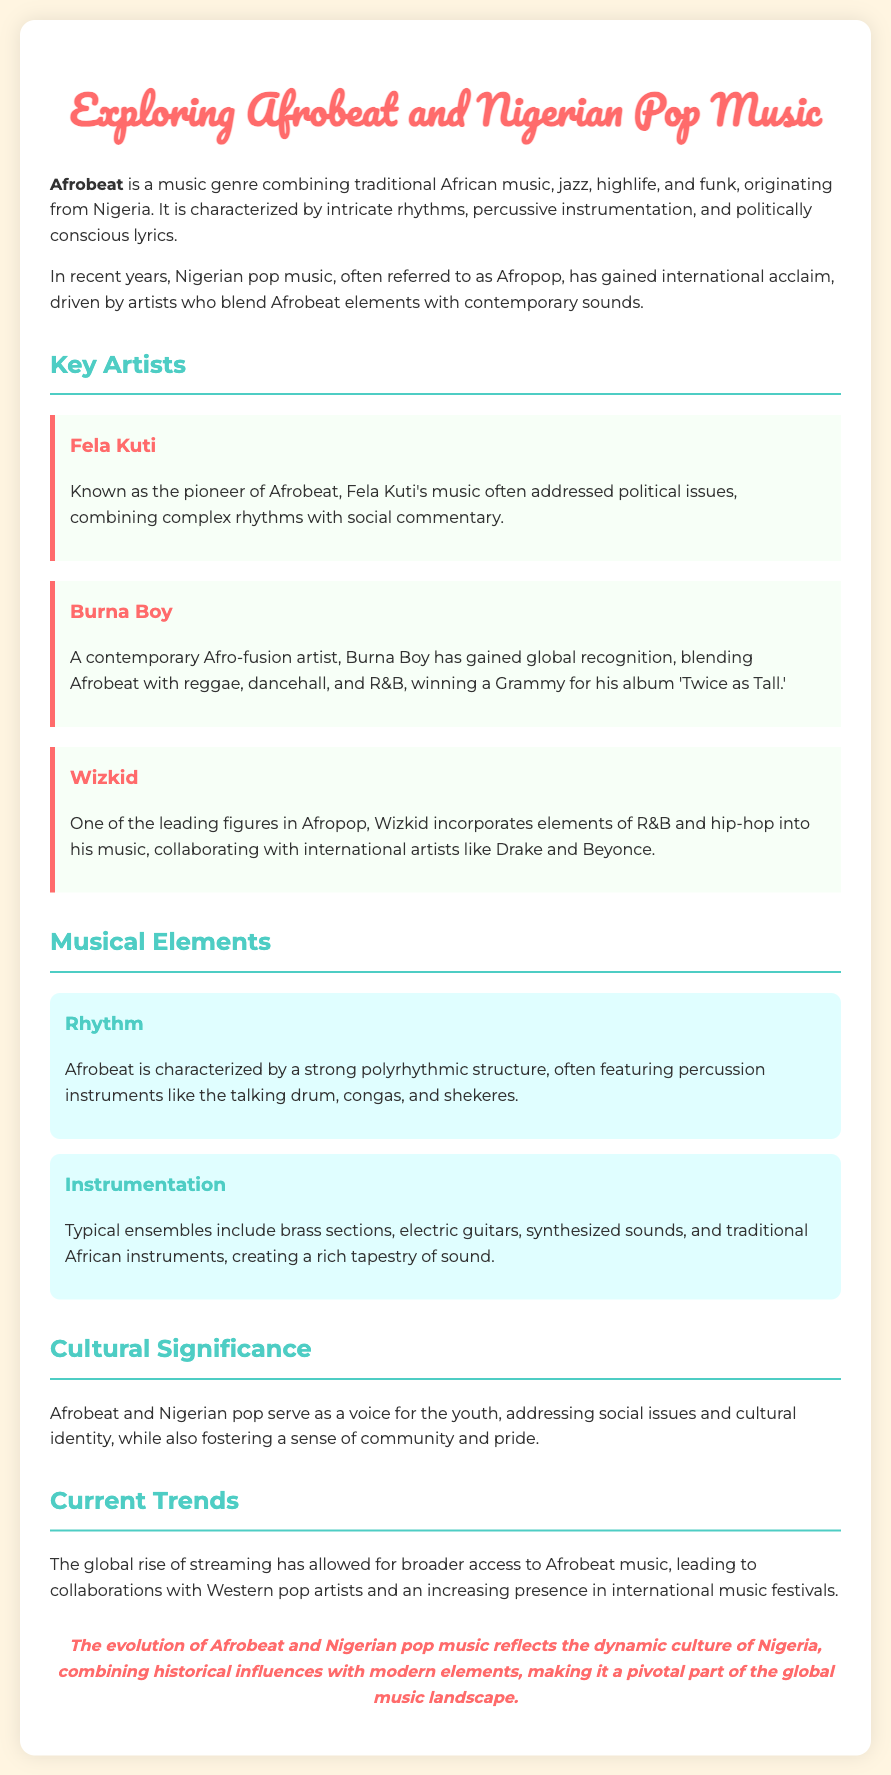What genre combines traditional African music, jazz, highlife, and funk? The document states that Afrobeat is a music genre that combines these elements.
Answer: Afrobeat Who is known as the pioneer of Afrobeat? The document mentions Fela Kuti as the pioneer of Afrobeat.
Answer: Fela Kuti Which artist won a Grammy for the album 'Twice as Tall'? The document specifies that Burna Boy won a Grammy for this album.
Answer: Burna Boy What is a characteristic feature of Afrobeat's rhythm? The document describes Afrobeat as having a strong polyrhythmic structure.
Answer: Polyrhythmic structure Which two genres does Wizkid incorporate into his music? The document indicates that Wizkid incorporates R&B and hip-hop.
Answer: R&B and hip-hop What type of cultural issues do Afrobeat and Nigerian pop music address? The document states that they serve as a voice for social issues and cultural identity.
Answer: Social issues and cultural identity What instruments are typically featured in Afrobeat? The document lists percussion instruments like talking drums, congas, and shekeres as part of Afrobeat.
Answer: Talking drums, congas, and shekeres What has allowed for broader access to Afrobeat music recently? The document notes the global rise of streaming as a factor for broader access.
Answer: Global rise of streaming How does the document describe the evolution of Afrobeat and Nigerian pop music? The document mentions that it reflects the dynamic culture of Nigeria, combining historical influences with modern elements.
Answer: Reflects the dynamic culture of Nigeria 